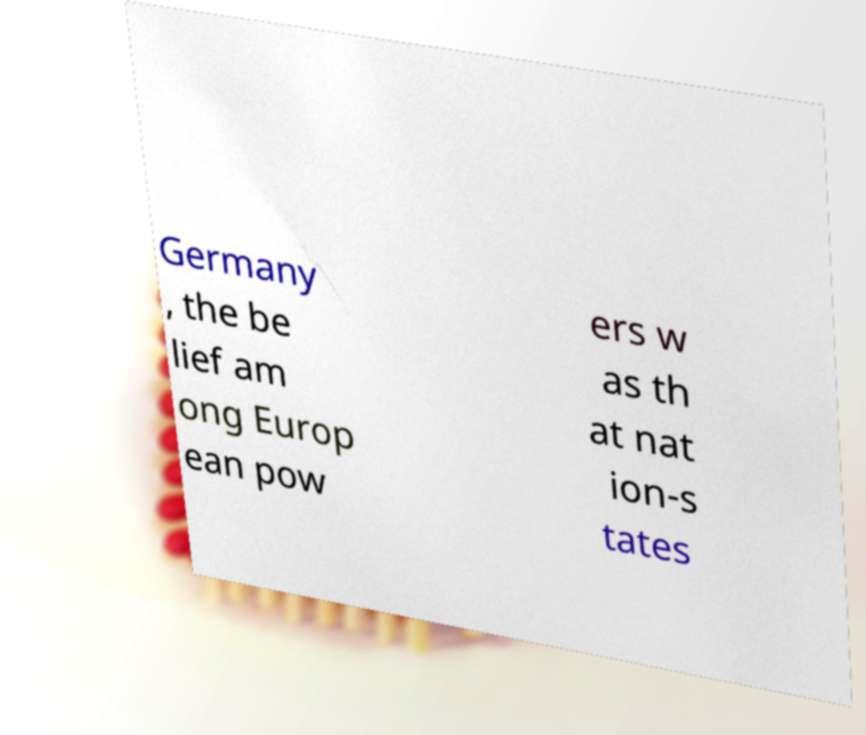There's text embedded in this image that I need extracted. Can you transcribe it verbatim? Germany , the be lief am ong Europ ean pow ers w as th at nat ion-s tates 